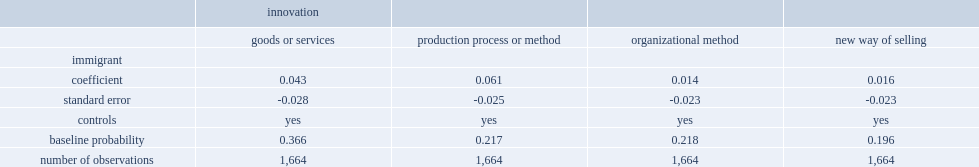What was the percentage points of immigrant-owned firms to implement a product or process innovation? 0.061. 